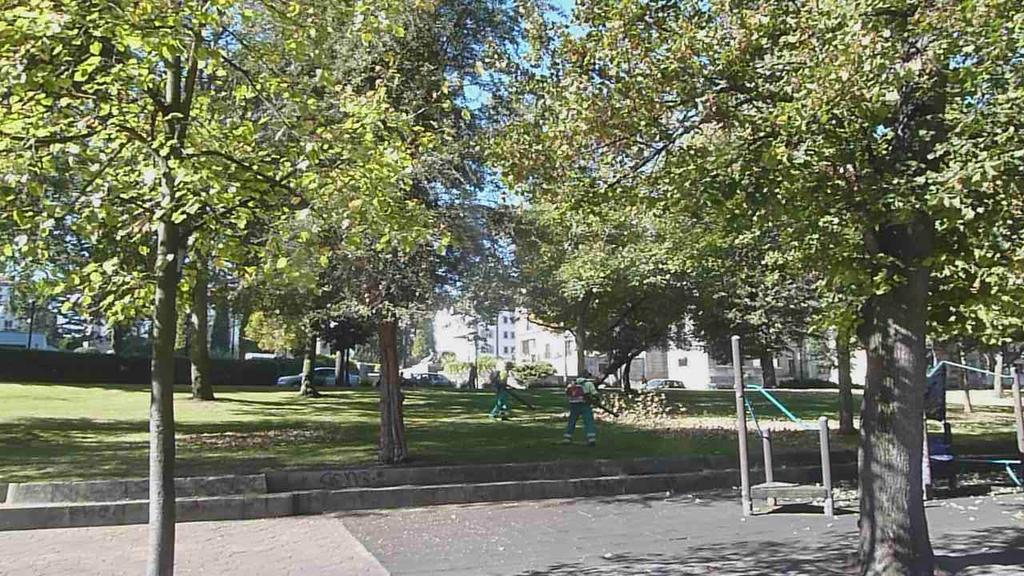What type of vegetation can be seen in the image? There are trees and grass in the image. What are the people doing in the image? Two people are present on the grass. What else can be seen in the image besides the trees and grass? There are vehicles and buildings visible in the image. How does the boot increase the speed of the trees in the image? There is no boot present in the image, and the trees are not moving or increasing in speed. 